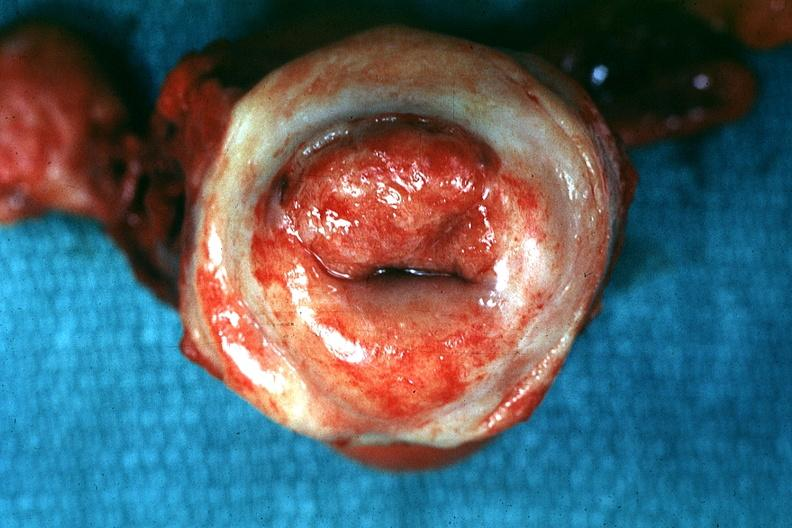what is present?
Answer the question using a single word or phrase. Uterus 